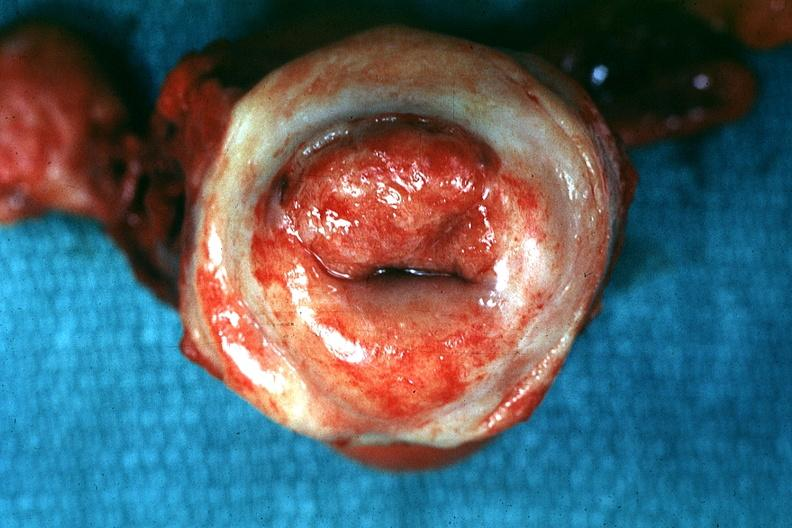what is present?
Answer the question using a single word or phrase. Uterus 